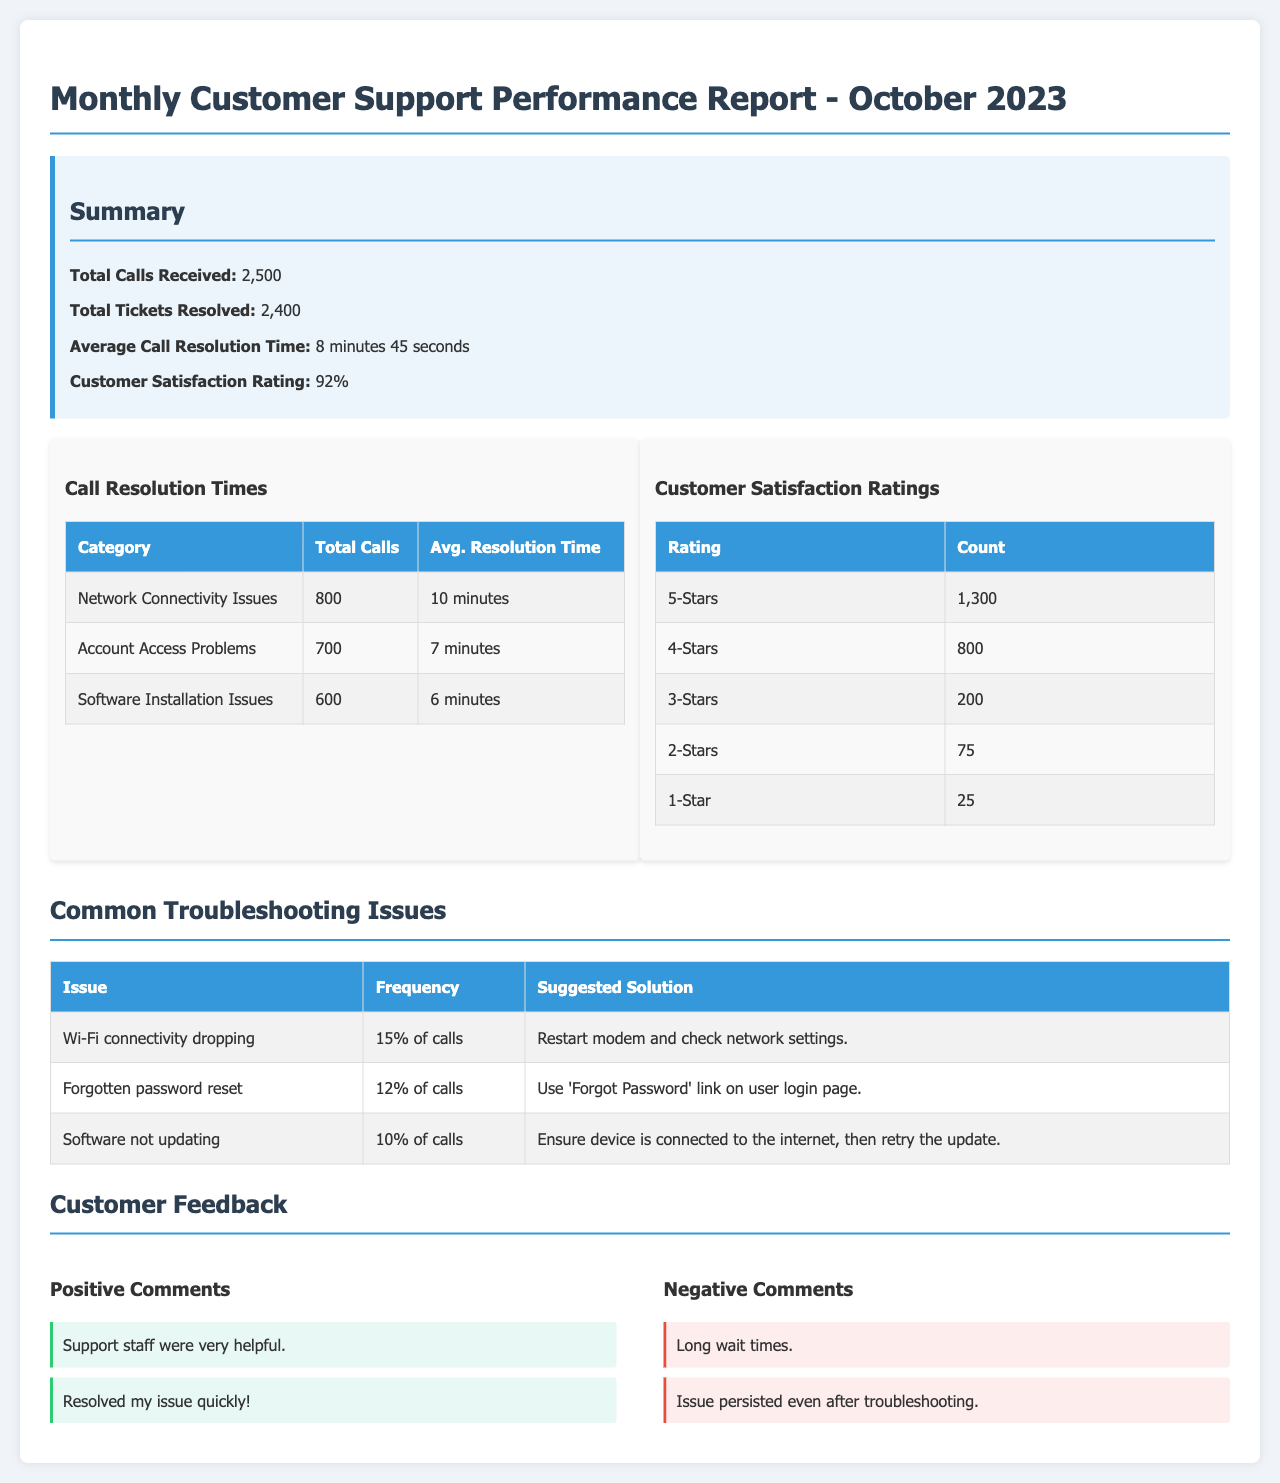What is the total number of calls received? The total number of calls received is stated in the summary section of the report.
Answer: 2,500 What percentage is the customer satisfaction rating? The customer satisfaction rating is provided in the summary section, indicating the level of satisfaction among customers.
Answer: 92% What issue had the highest frequency in calls? The common troubleshooting issues section lists the issues along with their frequencies, allowing us to identify the most common issue.
Answer: Wi-Fi connectivity dropping What is the average call resolution time? The average call resolution time is included in the summary part of the report, reflecting how quickly calls are resolved.
Answer: 8 minutes 45 seconds How many 5-star ratings were received from customers? The customer satisfaction ratings table details the count of ratings per category, including 5-stars.
Answer: 1,300 What was the suggested solution for forgotten password resets? The troubleshooting issues section outlines suggested solutions to common problems, including for forgotten passwords.
Answer: Use 'Forgot Password' link on user login page What percentage of calls were related to Wi-Fi connectivity issues? The frequency of the Wi-Fi connectivity issue can be calculated from the total calls and its listed frequency.
Answer: 15% of calls What is included in the negative comments section? The negative comments section lists customer feedback that was less favorable, providing insight into areas needing improvement.
Answer: Long wait times What type of document is this report? The title provides information about the nature and purpose of the document.
Answer: Performance Report 